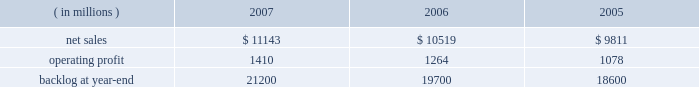Air mobility sales declined by $ 535 million primarily due to c-130j deliveries ( 12 in 2006 compared to 15 in 2005 ) and lower volume on the c-5 program .
Combat aircraft sales increased by $ 292 million mainly due to higher f-35 and f-22 volume , partially offset by reduced volume on f-16 programs .
Other aeronautics programs sales increased by $ 83 million primarily due to higher volume in sustainment services activities .
Operating profit for the segment increased 21% ( 21 % ) in 2007 compared to 2006 .
Operating profit increases in combat aircraft more than offset decreases in other aeronautics programs and air mobility .
Combat aircraft operating profit increased $ 326 million mainly due to improved performance on f-22 and f-16 programs .
Air mobility and other aeronautics programs declined $ 77 million due to lower operating profit in support and sustainment activities .
Operating profit for the segment increased 20% ( 20 % ) in 2006 compared to 2005 .
Operating profit increased in both combat aircraft and air mobility .
Combat aircraft increased $ 114 million , mainly due to higher volume on the f-35 and f-22 programs , and improved performance on f-16 programs .
The improvement for the year was also attributable in part to the fact that in 2005 , operating profit included a reduction in earnings on the f-35 program .
Air mobility operating profit increased $ 84 million , mainly due to improved performance on c-130j sustainment activities in 2006 .
Backlog decreased in 2007 as compared to 2006 primarily as a result of sales volume on the f-35 program .
This decrease was offset partially by increased orders on the f-22 and c-130j programs .
Electronic systems electronic systems 2019 operating results included the following : ( in millions ) 2007 2006 2005 .
Net sales for electronic systems increased by 6% ( 6 % ) in 2007 compared to 2006 .
Sales increased in missiles & fire control ( m&fc ) , maritime systems & sensors ( ms2 ) , and platform , training & energy ( pt&e ) .
M&fc sales increased $ 258 million mainly due to higher volume in fire control systems and air defense programs , which more than offset declines in tactical missile programs .
Ms2 sales grew $ 254 million due to volume increases in undersea and radar systems activities that were offset partially by decreases in surface systems activities .
Pt&e sales increased $ 113 million , primarily due to higher volume in platform integration activities , which more than offset declines in distribution technology activities .
Net sales for electronic systems increased by 7% ( 7 % ) in 2006 compared to 2005 .
Higher volume in platform integration activities led to increased sales of $ 329 million at pt&e .
Ms2 sales increased $ 267 million primarily due to surface systems activities .
Air defense programs contributed to increased sales of $ 118 million at m&fc .
Operating profit for the segment increased by 12% ( 12 % ) in 2007 compared to 2006 , representing an increase in all three lines of business during the year .
Operating profit increased $ 70 million at pt&e primarily due to higher volume and improved performance on platform integration activities .
Ms2 operating profit increased $ 32 million due to higher volume on undersea and tactical systems activities that more than offset lower volume on surface systems activities .
At m&fc , operating profit increased $ 32 million due to higher volume in fire control systems and improved performance in tactical missile programs , which partially were offset by performance on certain international air defense programs in 2006 .
Operating profit for the segment increased by 17% ( 17 % ) in 2006 compared to 2005 .
Operating profit increased by $ 74 million at ms2 mainly due to higher volume on surface systems and undersea programs .
Pt&e operating profit increased $ 61 million mainly due to improved performance on distribution technology activities .
Higher volume on air defense programs contributed to a $ 52 million increase in operating profit at m&fc .
The increase in backlog during 2007 over 2006 resulted primarily from increased orders for certain tactical missile programs and fire control systems at m&fc and platform integration programs at pt&e. .
What was the average operating profit from 2005 to 2007? 
Computations: (((1410 + 1264) + 1078) / 3)
Answer: 1250.66667. Air mobility sales declined by $ 535 million primarily due to c-130j deliveries ( 12 in 2006 compared to 15 in 2005 ) and lower volume on the c-5 program .
Combat aircraft sales increased by $ 292 million mainly due to higher f-35 and f-22 volume , partially offset by reduced volume on f-16 programs .
Other aeronautics programs sales increased by $ 83 million primarily due to higher volume in sustainment services activities .
Operating profit for the segment increased 21% ( 21 % ) in 2007 compared to 2006 .
Operating profit increases in combat aircraft more than offset decreases in other aeronautics programs and air mobility .
Combat aircraft operating profit increased $ 326 million mainly due to improved performance on f-22 and f-16 programs .
Air mobility and other aeronautics programs declined $ 77 million due to lower operating profit in support and sustainment activities .
Operating profit for the segment increased 20% ( 20 % ) in 2006 compared to 2005 .
Operating profit increased in both combat aircraft and air mobility .
Combat aircraft increased $ 114 million , mainly due to higher volume on the f-35 and f-22 programs , and improved performance on f-16 programs .
The improvement for the year was also attributable in part to the fact that in 2005 , operating profit included a reduction in earnings on the f-35 program .
Air mobility operating profit increased $ 84 million , mainly due to improved performance on c-130j sustainment activities in 2006 .
Backlog decreased in 2007 as compared to 2006 primarily as a result of sales volume on the f-35 program .
This decrease was offset partially by increased orders on the f-22 and c-130j programs .
Electronic systems electronic systems 2019 operating results included the following : ( in millions ) 2007 2006 2005 .
Net sales for electronic systems increased by 6% ( 6 % ) in 2007 compared to 2006 .
Sales increased in missiles & fire control ( m&fc ) , maritime systems & sensors ( ms2 ) , and platform , training & energy ( pt&e ) .
M&fc sales increased $ 258 million mainly due to higher volume in fire control systems and air defense programs , which more than offset declines in tactical missile programs .
Ms2 sales grew $ 254 million due to volume increases in undersea and radar systems activities that were offset partially by decreases in surface systems activities .
Pt&e sales increased $ 113 million , primarily due to higher volume in platform integration activities , which more than offset declines in distribution technology activities .
Net sales for electronic systems increased by 7% ( 7 % ) in 2006 compared to 2005 .
Higher volume in platform integration activities led to increased sales of $ 329 million at pt&e .
Ms2 sales increased $ 267 million primarily due to surface systems activities .
Air defense programs contributed to increased sales of $ 118 million at m&fc .
Operating profit for the segment increased by 12% ( 12 % ) in 2007 compared to 2006 , representing an increase in all three lines of business during the year .
Operating profit increased $ 70 million at pt&e primarily due to higher volume and improved performance on platform integration activities .
Ms2 operating profit increased $ 32 million due to higher volume on undersea and tactical systems activities that more than offset lower volume on surface systems activities .
At m&fc , operating profit increased $ 32 million due to higher volume in fire control systems and improved performance in tactical missile programs , which partially were offset by performance on certain international air defense programs in 2006 .
Operating profit for the segment increased by 17% ( 17 % ) in 2006 compared to 2005 .
Operating profit increased by $ 74 million at ms2 mainly due to higher volume on surface systems and undersea programs .
Pt&e operating profit increased $ 61 million mainly due to improved performance on distribution technology activities .
Higher volume on air defense programs contributed to a $ 52 million increase in operating profit at m&fc .
The increase in backlog during 2007 over 2006 resulted primarily from increased orders for certain tactical missile programs and fire control systems at m&fc and platform integration programs at pt&e. .
In 2007 what was the ratio of the increase in the combat aircraft sales to the other aeronautics programs sales? 
Computations: (292 / 83)
Answer: 3.51807. 